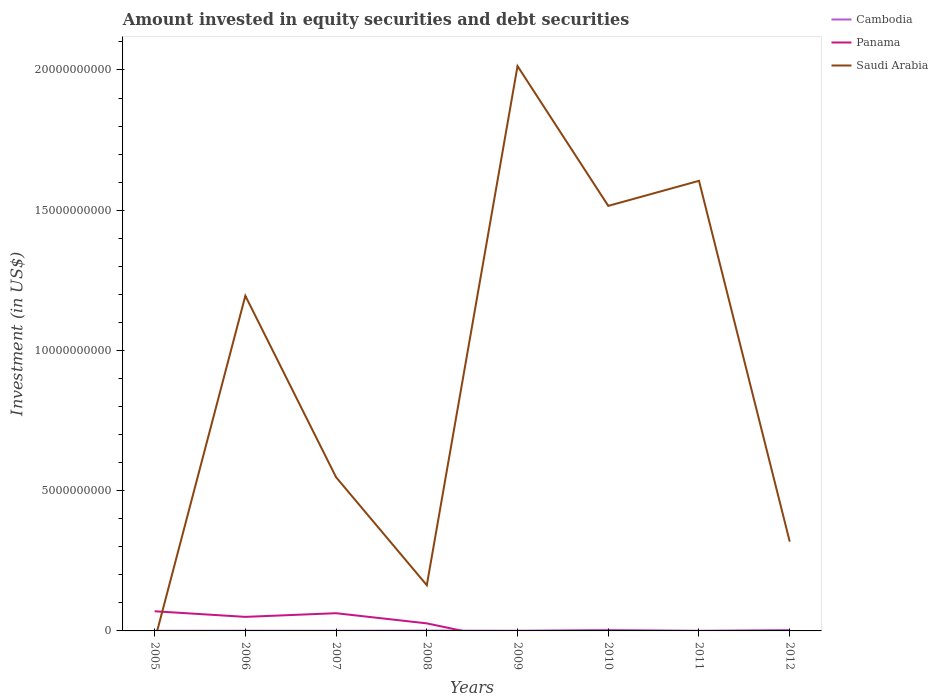What is the total amount invested in equity securities and debt securities in Saudi Arabia in the graph?
Your answer should be very brief. 4.98e+09. What is the difference between the highest and the second highest amount invested in equity securities and debt securities in Panama?
Your answer should be compact. 7.01e+08. What is the difference between the highest and the lowest amount invested in equity securities and debt securities in Saudi Arabia?
Your answer should be compact. 4. Is the amount invested in equity securities and debt securities in Panama strictly greater than the amount invested in equity securities and debt securities in Saudi Arabia over the years?
Offer a terse response. No. How many years are there in the graph?
Provide a succinct answer. 8. What is the difference between two consecutive major ticks on the Y-axis?
Ensure brevity in your answer.  5.00e+09. Are the values on the major ticks of Y-axis written in scientific E-notation?
Give a very brief answer. No. Does the graph contain grids?
Your response must be concise. No. Where does the legend appear in the graph?
Keep it short and to the point. Top right. How are the legend labels stacked?
Provide a short and direct response. Vertical. What is the title of the graph?
Provide a succinct answer. Amount invested in equity securities and debt securities. What is the label or title of the Y-axis?
Provide a short and direct response. Investment (in US$). What is the Investment (in US$) of Cambodia in 2005?
Offer a terse response. 4.87e+06. What is the Investment (in US$) of Panama in 2005?
Provide a short and direct response. 7.01e+08. What is the Investment (in US$) of Cambodia in 2006?
Give a very brief answer. 7.58e+06. What is the Investment (in US$) in Panama in 2006?
Give a very brief answer. 5.01e+08. What is the Investment (in US$) in Saudi Arabia in 2006?
Keep it short and to the point. 1.19e+1. What is the Investment (in US$) in Cambodia in 2007?
Provide a succinct answer. 6.33e+06. What is the Investment (in US$) in Panama in 2007?
Your answer should be very brief. 6.32e+08. What is the Investment (in US$) in Saudi Arabia in 2007?
Provide a succinct answer. 5.48e+09. What is the Investment (in US$) of Cambodia in 2008?
Make the answer very short. 1.16e+07. What is the Investment (in US$) in Panama in 2008?
Your answer should be compact. 2.70e+08. What is the Investment (in US$) of Saudi Arabia in 2008?
Provide a succinct answer. 1.63e+09. What is the Investment (in US$) in Cambodia in 2009?
Make the answer very short. 7.62e+06. What is the Investment (in US$) in Panama in 2009?
Your response must be concise. 0. What is the Investment (in US$) of Saudi Arabia in 2009?
Offer a terse response. 2.01e+1. What is the Investment (in US$) of Cambodia in 2010?
Offer a very short reply. 3.67e+07. What is the Investment (in US$) of Panama in 2010?
Provide a succinct answer. 0. What is the Investment (in US$) of Saudi Arabia in 2010?
Your response must be concise. 1.52e+1. What is the Investment (in US$) of Cambodia in 2011?
Your response must be concise. 6.14e+06. What is the Investment (in US$) in Panama in 2011?
Give a very brief answer. 0. What is the Investment (in US$) in Saudi Arabia in 2011?
Ensure brevity in your answer.  1.60e+1. What is the Investment (in US$) of Cambodia in 2012?
Your response must be concise. 3.42e+07. What is the Investment (in US$) of Panama in 2012?
Provide a short and direct response. 0. What is the Investment (in US$) in Saudi Arabia in 2012?
Offer a very short reply. 3.18e+09. Across all years, what is the maximum Investment (in US$) of Cambodia?
Your response must be concise. 3.67e+07. Across all years, what is the maximum Investment (in US$) of Panama?
Offer a terse response. 7.01e+08. Across all years, what is the maximum Investment (in US$) of Saudi Arabia?
Keep it short and to the point. 2.01e+1. Across all years, what is the minimum Investment (in US$) in Cambodia?
Provide a short and direct response. 4.87e+06. Across all years, what is the minimum Investment (in US$) in Saudi Arabia?
Your response must be concise. 0. What is the total Investment (in US$) in Cambodia in the graph?
Make the answer very short. 1.15e+08. What is the total Investment (in US$) in Panama in the graph?
Keep it short and to the point. 2.10e+09. What is the total Investment (in US$) of Saudi Arabia in the graph?
Make the answer very short. 7.36e+1. What is the difference between the Investment (in US$) in Cambodia in 2005 and that in 2006?
Make the answer very short. -2.72e+06. What is the difference between the Investment (in US$) in Panama in 2005 and that in 2006?
Provide a short and direct response. 2.00e+08. What is the difference between the Investment (in US$) of Cambodia in 2005 and that in 2007?
Your answer should be very brief. -1.47e+06. What is the difference between the Investment (in US$) of Panama in 2005 and that in 2007?
Offer a terse response. 6.92e+07. What is the difference between the Investment (in US$) of Cambodia in 2005 and that in 2008?
Your answer should be very brief. -6.72e+06. What is the difference between the Investment (in US$) of Panama in 2005 and that in 2008?
Give a very brief answer. 4.31e+08. What is the difference between the Investment (in US$) of Cambodia in 2005 and that in 2009?
Your response must be concise. -2.75e+06. What is the difference between the Investment (in US$) of Cambodia in 2005 and that in 2010?
Keep it short and to the point. -3.18e+07. What is the difference between the Investment (in US$) in Cambodia in 2005 and that in 2011?
Your answer should be very brief. -1.27e+06. What is the difference between the Investment (in US$) of Cambodia in 2005 and that in 2012?
Ensure brevity in your answer.  -2.93e+07. What is the difference between the Investment (in US$) of Cambodia in 2006 and that in 2007?
Provide a succinct answer. 1.25e+06. What is the difference between the Investment (in US$) of Panama in 2006 and that in 2007?
Your answer should be compact. -1.31e+08. What is the difference between the Investment (in US$) of Saudi Arabia in 2006 and that in 2007?
Your response must be concise. 6.47e+09. What is the difference between the Investment (in US$) of Cambodia in 2006 and that in 2008?
Your answer should be compact. -4.00e+06. What is the difference between the Investment (in US$) of Panama in 2006 and that in 2008?
Your response must be concise. 2.32e+08. What is the difference between the Investment (in US$) in Saudi Arabia in 2006 and that in 2008?
Keep it short and to the point. 1.03e+1. What is the difference between the Investment (in US$) of Cambodia in 2006 and that in 2009?
Your response must be concise. -3.82e+04. What is the difference between the Investment (in US$) of Saudi Arabia in 2006 and that in 2009?
Provide a short and direct response. -8.19e+09. What is the difference between the Investment (in US$) in Cambodia in 2006 and that in 2010?
Ensure brevity in your answer.  -2.91e+07. What is the difference between the Investment (in US$) of Saudi Arabia in 2006 and that in 2010?
Make the answer very short. -3.21e+09. What is the difference between the Investment (in US$) in Cambodia in 2006 and that in 2011?
Ensure brevity in your answer.  1.45e+06. What is the difference between the Investment (in US$) of Saudi Arabia in 2006 and that in 2011?
Your answer should be very brief. -4.10e+09. What is the difference between the Investment (in US$) of Cambodia in 2006 and that in 2012?
Offer a terse response. -2.66e+07. What is the difference between the Investment (in US$) in Saudi Arabia in 2006 and that in 2012?
Your response must be concise. 8.76e+09. What is the difference between the Investment (in US$) in Cambodia in 2007 and that in 2008?
Ensure brevity in your answer.  -5.25e+06. What is the difference between the Investment (in US$) of Panama in 2007 and that in 2008?
Provide a short and direct response. 3.62e+08. What is the difference between the Investment (in US$) of Saudi Arabia in 2007 and that in 2008?
Keep it short and to the point. 3.85e+09. What is the difference between the Investment (in US$) of Cambodia in 2007 and that in 2009?
Ensure brevity in your answer.  -1.29e+06. What is the difference between the Investment (in US$) of Saudi Arabia in 2007 and that in 2009?
Your response must be concise. -1.47e+1. What is the difference between the Investment (in US$) in Cambodia in 2007 and that in 2010?
Offer a very short reply. -3.03e+07. What is the difference between the Investment (in US$) of Saudi Arabia in 2007 and that in 2010?
Make the answer very short. -9.67e+09. What is the difference between the Investment (in US$) in Cambodia in 2007 and that in 2011?
Make the answer very short. 1.96e+05. What is the difference between the Investment (in US$) in Saudi Arabia in 2007 and that in 2011?
Make the answer very short. -1.06e+1. What is the difference between the Investment (in US$) of Cambodia in 2007 and that in 2012?
Provide a short and direct response. -2.78e+07. What is the difference between the Investment (in US$) of Saudi Arabia in 2007 and that in 2012?
Offer a very short reply. 2.30e+09. What is the difference between the Investment (in US$) in Cambodia in 2008 and that in 2009?
Keep it short and to the point. 3.97e+06. What is the difference between the Investment (in US$) of Saudi Arabia in 2008 and that in 2009?
Offer a very short reply. -1.85e+1. What is the difference between the Investment (in US$) of Cambodia in 2008 and that in 2010?
Offer a terse response. -2.51e+07. What is the difference between the Investment (in US$) in Saudi Arabia in 2008 and that in 2010?
Offer a very short reply. -1.35e+1. What is the difference between the Investment (in US$) of Cambodia in 2008 and that in 2011?
Your answer should be compact. 5.45e+06. What is the difference between the Investment (in US$) of Saudi Arabia in 2008 and that in 2011?
Your answer should be very brief. -1.44e+1. What is the difference between the Investment (in US$) in Cambodia in 2008 and that in 2012?
Offer a terse response. -2.26e+07. What is the difference between the Investment (in US$) of Saudi Arabia in 2008 and that in 2012?
Ensure brevity in your answer.  -1.55e+09. What is the difference between the Investment (in US$) of Cambodia in 2009 and that in 2010?
Your answer should be very brief. -2.90e+07. What is the difference between the Investment (in US$) in Saudi Arabia in 2009 and that in 2010?
Make the answer very short. 4.98e+09. What is the difference between the Investment (in US$) of Cambodia in 2009 and that in 2011?
Ensure brevity in your answer.  1.48e+06. What is the difference between the Investment (in US$) in Saudi Arabia in 2009 and that in 2011?
Make the answer very short. 4.09e+09. What is the difference between the Investment (in US$) of Cambodia in 2009 and that in 2012?
Ensure brevity in your answer.  -2.66e+07. What is the difference between the Investment (in US$) of Saudi Arabia in 2009 and that in 2012?
Ensure brevity in your answer.  1.70e+1. What is the difference between the Investment (in US$) of Cambodia in 2010 and that in 2011?
Your response must be concise. 3.05e+07. What is the difference between the Investment (in US$) of Saudi Arabia in 2010 and that in 2011?
Offer a very short reply. -8.93e+08. What is the difference between the Investment (in US$) in Cambodia in 2010 and that in 2012?
Keep it short and to the point. 2.49e+06. What is the difference between the Investment (in US$) in Saudi Arabia in 2010 and that in 2012?
Your answer should be compact. 1.20e+1. What is the difference between the Investment (in US$) of Cambodia in 2011 and that in 2012?
Your answer should be compact. -2.80e+07. What is the difference between the Investment (in US$) in Saudi Arabia in 2011 and that in 2012?
Your answer should be compact. 1.29e+1. What is the difference between the Investment (in US$) in Cambodia in 2005 and the Investment (in US$) in Panama in 2006?
Provide a short and direct response. -4.96e+08. What is the difference between the Investment (in US$) of Cambodia in 2005 and the Investment (in US$) of Saudi Arabia in 2006?
Ensure brevity in your answer.  -1.19e+1. What is the difference between the Investment (in US$) of Panama in 2005 and the Investment (in US$) of Saudi Arabia in 2006?
Give a very brief answer. -1.12e+1. What is the difference between the Investment (in US$) in Cambodia in 2005 and the Investment (in US$) in Panama in 2007?
Your answer should be compact. -6.27e+08. What is the difference between the Investment (in US$) of Cambodia in 2005 and the Investment (in US$) of Saudi Arabia in 2007?
Provide a short and direct response. -5.47e+09. What is the difference between the Investment (in US$) of Panama in 2005 and the Investment (in US$) of Saudi Arabia in 2007?
Provide a short and direct response. -4.78e+09. What is the difference between the Investment (in US$) of Cambodia in 2005 and the Investment (in US$) of Panama in 2008?
Your answer should be very brief. -2.65e+08. What is the difference between the Investment (in US$) in Cambodia in 2005 and the Investment (in US$) in Saudi Arabia in 2008?
Your answer should be very brief. -1.63e+09. What is the difference between the Investment (in US$) of Panama in 2005 and the Investment (in US$) of Saudi Arabia in 2008?
Your answer should be very brief. -9.30e+08. What is the difference between the Investment (in US$) of Cambodia in 2005 and the Investment (in US$) of Saudi Arabia in 2009?
Your response must be concise. -2.01e+1. What is the difference between the Investment (in US$) in Panama in 2005 and the Investment (in US$) in Saudi Arabia in 2009?
Your answer should be compact. -1.94e+1. What is the difference between the Investment (in US$) in Cambodia in 2005 and the Investment (in US$) in Saudi Arabia in 2010?
Your response must be concise. -1.51e+1. What is the difference between the Investment (in US$) of Panama in 2005 and the Investment (in US$) of Saudi Arabia in 2010?
Keep it short and to the point. -1.45e+1. What is the difference between the Investment (in US$) in Cambodia in 2005 and the Investment (in US$) in Saudi Arabia in 2011?
Your answer should be very brief. -1.60e+1. What is the difference between the Investment (in US$) of Panama in 2005 and the Investment (in US$) of Saudi Arabia in 2011?
Keep it short and to the point. -1.53e+1. What is the difference between the Investment (in US$) of Cambodia in 2005 and the Investment (in US$) of Saudi Arabia in 2012?
Make the answer very short. -3.18e+09. What is the difference between the Investment (in US$) in Panama in 2005 and the Investment (in US$) in Saudi Arabia in 2012?
Keep it short and to the point. -2.48e+09. What is the difference between the Investment (in US$) in Cambodia in 2006 and the Investment (in US$) in Panama in 2007?
Provide a short and direct response. -6.24e+08. What is the difference between the Investment (in US$) in Cambodia in 2006 and the Investment (in US$) in Saudi Arabia in 2007?
Provide a short and direct response. -5.47e+09. What is the difference between the Investment (in US$) of Panama in 2006 and the Investment (in US$) of Saudi Arabia in 2007?
Your response must be concise. -4.98e+09. What is the difference between the Investment (in US$) of Cambodia in 2006 and the Investment (in US$) of Panama in 2008?
Give a very brief answer. -2.62e+08. What is the difference between the Investment (in US$) of Cambodia in 2006 and the Investment (in US$) of Saudi Arabia in 2008?
Offer a very short reply. -1.62e+09. What is the difference between the Investment (in US$) in Panama in 2006 and the Investment (in US$) in Saudi Arabia in 2008?
Offer a very short reply. -1.13e+09. What is the difference between the Investment (in US$) of Cambodia in 2006 and the Investment (in US$) of Saudi Arabia in 2009?
Provide a short and direct response. -2.01e+1. What is the difference between the Investment (in US$) of Panama in 2006 and the Investment (in US$) of Saudi Arabia in 2009?
Offer a terse response. -1.96e+1. What is the difference between the Investment (in US$) in Cambodia in 2006 and the Investment (in US$) in Saudi Arabia in 2010?
Provide a short and direct response. -1.51e+1. What is the difference between the Investment (in US$) of Panama in 2006 and the Investment (in US$) of Saudi Arabia in 2010?
Your answer should be very brief. -1.47e+1. What is the difference between the Investment (in US$) in Cambodia in 2006 and the Investment (in US$) in Saudi Arabia in 2011?
Your response must be concise. -1.60e+1. What is the difference between the Investment (in US$) of Panama in 2006 and the Investment (in US$) of Saudi Arabia in 2011?
Offer a terse response. -1.55e+1. What is the difference between the Investment (in US$) of Cambodia in 2006 and the Investment (in US$) of Saudi Arabia in 2012?
Your response must be concise. -3.18e+09. What is the difference between the Investment (in US$) of Panama in 2006 and the Investment (in US$) of Saudi Arabia in 2012?
Ensure brevity in your answer.  -2.68e+09. What is the difference between the Investment (in US$) of Cambodia in 2007 and the Investment (in US$) of Panama in 2008?
Provide a short and direct response. -2.63e+08. What is the difference between the Investment (in US$) in Cambodia in 2007 and the Investment (in US$) in Saudi Arabia in 2008?
Offer a terse response. -1.62e+09. What is the difference between the Investment (in US$) in Panama in 2007 and the Investment (in US$) in Saudi Arabia in 2008?
Your answer should be very brief. -9.99e+08. What is the difference between the Investment (in US$) in Cambodia in 2007 and the Investment (in US$) in Saudi Arabia in 2009?
Your response must be concise. -2.01e+1. What is the difference between the Investment (in US$) of Panama in 2007 and the Investment (in US$) of Saudi Arabia in 2009?
Provide a short and direct response. -1.95e+1. What is the difference between the Investment (in US$) of Cambodia in 2007 and the Investment (in US$) of Saudi Arabia in 2010?
Provide a succinct answer. -1.51e+1. What is the difference between the Investment (in US$) of Panama in 2007 and the Investment (in US$) of Saudi Arabia in 2010?
Offer a terse response. -1.45e+1. What is the difference between the Investment (in US$) in Cambodia in 2007 and the Investment (in US$) in Saudi Arabia in 2011?
Provide a succinct answer. -1.60e+1. What is the difference between the Investment (in US$) of Panama in 2007 and the Investment (in US$) of Saudi Arabia in 2011?
Give a very brief answer. -1.54e+1. What is the difference between the Investment (in US$) in Cambodia in 2007 and the Investment (in US$) in Saudi Arabia in 2012?
Your response must be concise. -3.18e+09. What is the difference between the Investment (in US$) of Panama in 2007 and the Investment (in US$) of Saudi Arabia in 2012?
Give a very brief answer. -2.55e+09. What is the difference between the Investment (in US$) of Cambodia in 2008 and the Investment (in US$) of Saudi Arabia in 2009?
Your answer should be compact. -2.01e+1. What is the difference between the Investment (in US$) in Panama in 2008 and the Investment (in US$) in Saudi Arabia in 2009?
Your answer should be very brief. -1.99e+1. What is the difference between the Investment (in US$) in Cambodia in 2008 and the Investment (in US$) in Saudi Arabia in 2010?
Give a very brief answer. -1.51e+1. What is the difference between the Investment (in US$) in Panama in 2008 and the Investment (in US$) in Saudi Arabia in 2010?
Provide a short and direct response. -1.49e+1. What is the difference between the Investment (in US$) of Cambodia in 2008 and the Investment (in US$) of Saudi Arabia in 2011?
Your answer should be very brief. -1.60e+1. What is the difference between the Investment (in US$) of Panama in 2008 and the Investment (in US$) of Saudi Arabia in 2011?
Give a very brief answer. -1.58e+1. What is the difference between the Investment (in US$) in Cambodia in 2008 and the Investment (in US$) in Saudi Arabia in 2012?
Your answer should be compact. -3.17e+09. What is the difference between the Investment (in US$) in Panama in 2008 and the Investment (in US$) in Saudi Arabia in 2012?
Keep it short and to the point. -2.91e+09. What is the difference between the Investment (in US$) of Cambodia in 2009 and the Investment (in US$) of Saudi Arabia in 2010?
Provide a succinct answer. -1.51e+1. What is the difference between the Investment (in US$) of Cambodia in 2009 and the Investment (in US$) of Saudi Arabia in 2011?
Provide a short and direct response. -1.60e+1. What is the difference between the Investment (in US$) in Cambodia in 2009 and the Investment (in US$) in Saudi Arabia in 2012?
Provide a succinct answer. -3.18e+09. What is the difference between the Investment (in US$) of Cambodia in 2010 and the Investment (in US$) of Saudi Arabia in 2011?
Make the answer very short. -1.60e+1. What is the difference between the Investment (in US$) in Cambodia in 2010 and the Investment (in US$) in Saudi Arabia in 2012?
Your response must be concise. -3.15e+09. What is the difference between the Investment (in US$) in Cambodia in 2011 and the Investment (in US$) in Saudi Arabia in 2012?
Make the answer very short. -3.18e+09. What is the average Investment (in US$) in Cambodia per year?
Give a very brief answer. 1.44e+07. What is the average Investment (in US$) of Panama per year?
Offer a very short reply. 2.63e+08. What is the average Investment (in US$) of Saudi Arabia per year?
Ensure brevity in your answer.  9.20e+09. In the year 2005, what is the difference between the Investment (in US$) in Cambodia and Investment (in US$) in Panama?
Offer a very short reply. -6.96e+08. In the year 2006, what is the difference between the Investment (in US$) of Cambodia and Investment (in US$) of Panama?
Offer a terse response. -4.93e+08. In the year 2006, what is the difference between the Investment (in US$) in Cambodia and Investment (in US$) in Saudi Arabia?
Your answer should be compact. -1.19e+1. In the year 2006, what is the difference between the Investment (in US$) in Panama and Investment (in US$) in Saudi Arabia?
Your answer should be compact. -1.14e+1. In the year 2007, what is the difference between the Investment (in US$) in Cambodia and Investment (in US$) in Panama?
Provide a succinct answer. -6.25e+08. In the year 2007, what is the difference between the Investment (in US$) in Cambodia and Investment (in US$) in Saudi Arabia?
Your answer should be very brief. -5.47e+09. In the year 2007, what is the difference between the Investment (in US$) of Panama and Investment (in US$) of Saudi Arabia?
Offer a terse response. -4.85e+09. In the year 2008, what is the difference between the Investment (in US$) in Cambodia and Investment (in US$) in Panama?
Provide a short and direct response. -2.58e+08. In the year 2008, what is the difference between the Investment (in US$) of Cambodia and Investment (in US$) of Saudi Arabia?
Keep it short and to the point. -1.62e+09. In the year 2008, what is the difference between the Investment (in US$) of Panama and Investment (in US$) of Saudi Arabia?
Make the answer very short. -1.36e+09. In the year 2009, what is the difference between the Investment (in US$) in Cambodia and Investment (in US$) in Saudi Arabia?
Give a very brief answer. -2.01e+1. In the year 2010, what is the difference between the Investment (in US$) of Cambodia and Investment (in US$) of Saudi Arabia?
Offer a terse response. -1.51e+1. In the year 2011, what is the difference between the Investment (in US$) in Cambodia and Investment (in US$) in Saudi Arabia?
Your answer should be compact. -1.60e+1. In the year 2012, what is the difference between the Investment (in US$) in Cambodia and Investment (in US$) in Saudi Arabia?
Offer a very short reply. -3.15e+09. What is the ratio of the Investment (in US$) in Cambodia in 2005 to that in 2006?
Your answer should be very brief. 0.64. What is the ratio of the Investment (in US$) in Panama in 2005 to that in 2006?
Ensure brevity in your answer.  1.4. What is the ratio of the Investment (in US$) in Cambodia in 2005 to that in 2007?
Your answer should be very brief. 0.77. What is the ratio of the Investment (in US$) of Panama in 2005 to that in 2007?
Provide a succinct answer. 1.11. What is the ratio of the Investment (in US$) in Cambodia in 2005 to that in 2008?
Ensure brevity in your answer.  0.42. What is the ratio of the Investment (in US$) of Panama in 2005 to that in 2008?
Keep it short and to the point. 2.6. What is the ratio of the Investment (in US$) in Cambodia in 2005 to that in 2009?
Offer a terse response. 0.64. What is the ratio of the Investment (in US$) in Cambodia in 2005 to that in 2010?
Provide a succinct answer. 0.13. What is the ratio of the Investment (in US$) of Cambodia in 2005 to that in 2011?
Keep it short and to the point. 0.79. What is the ratio of the Investment (in US$) of Cambodia in 2005 to that in 2012?
Your answer should be compact. 0.14. What is the ratio of the Investment (in US$) in Cambodia in 2006 to that in 2007?
Offer a very short reply. 1.2. What is the ratio of the Investment (in US$) in Panama in 2006 to that in 2007?
Keep it short and to the point. 0.79. What is the ratio of the Investment (in US$) of Saudi Arabia in 2006 to that in 2007?
Provide a short and direct response. 2.18. What is the ratio of the Investment (in US$) of Cambodia in 2006 to that in 2008?
Your response must be concise. 0.65. What is the ratio of the Investment (in US$) of Panama in 2006 to that in 2008?
Provide a short and direct response. 1.86. What is the ratio of the Investment (in US$) of Saudi Arabia in 2006 to that in 2008?
Give a very brief answer. 7.33. What is the ratio of the Investment (in US$) of Cambodia in 2006 to that in 2009?
Offer a very short reply. 0.99. What is the ratio of the Investment (in US$) in Saudi Arabia in 2006 to that in 2009?
Your answer should be compact. 0.59. What is the ratio of the Investment (in US$) of Cambodia in 2006 to that in 2010?
Keep it short and to the point. 0.21. What is the ratio of the Investment (in US$) of Saudi Arabia in 2006 to that in 2010?
Your answer should be compact. 0.79. What is the ratio of the Investment (in US$) in Cambodia in 2006 to that in 2011?
Offer a terse response. 1.24. What is the ratio of the Investment (in US$) in Saudi Arabia in 2006 to that in 2011?
Your answer should be compact. 0.74. What is the ratio of the Investment (in US$) of Cambodia in 2006 to that in 2012?
Your answer should be compact. 0.22. What is the ratio of the Investment (in US$) in Saudi Arabia in 2006 to that in 2012?
Make the answer very short. 3.75. What is the ratio of the Investment (in US$) of Cambodia in 2007 to that in 2008?
Ensure brevity in your answer.  0.55. What is the ratio of the Investment (in US$) of Panama in 2007 to that in 2008?
Provide a short and direct response. 2.34. What is the ratio of the Investment (in US$) of Saudi Arabia in 2007 to that in 2008?
Provide a short and direct response. 3.36. What is the ratio of the Investment (in US$) of Cambodia in 2007 to that in 2009?
Offer a very short reply. 0.83. What is the ratio of the Investment (in US$) in Saudi Arabia in 2007 to that in 2009?
Your answer should be compact. 0.27. What is the ratio of the Investment (in US$) of Cambodia in 2007 to that in 2010?
Provide a short and direct response. 0.17. What is the ratio of the Investment (in US$) in Saudi Arabia in 2007 to that in 2010?
Your answer should be compact. 0.36. What is the ratio of the Investment (in US$) of Cambodia in 2007 to that in 2011?
Give a very brief answer. 1.03. What is the ratio of the Investment (in US$) of Saudi Arabia in 2007 to that in 2011?
Make the answer very short. 0.34. What is the ratio of the Investment (in US$) of Cambodia in 2007 to that in 2012?
Offer a terse response. 0.19. What is the ratio of the Investment (in US$) of Saudi Arabia in 2007 to that in 2012?
Make the answer very short. 1.72. What is the ratio of the Investment (in US$) in Cambodia in 2008 to that in 2009?
Keep it short and to the point. 1.52. What is the ratio of the Investment (in US$) of Saudi Arabia in 2008 to that in 2009?
Your answer should be very brief. 0.08. What is the ratio of the Investment (in US$) in Cambodia in 2008 to that in 2010?
Your answer should be compact. 0.32. What is the ratio of the Investment (in US$) of Saudi Arabia in 2008 to that in 2010?
Keep it short and to the point. 0.11. What is the ratio of the Investment (in US$) in Cambodia in 2008 to that in 2011?
Offer a terse response. 1.89. What is the ratio of the Investment (in US$) in Saudi Arabia in 2008 to that in 2011?
Provide a short and direct response. 0.1. What is the ratio of the Investment (in US$) of Cambodia in 2008 to that in 2012?
Provide a short and direct response. 0.34. What is the ratio of the Investment (in US$) in Saudi Arabia in 2008 to that in 2012?
Your answer should be very brief. 0.51. What is the ratio of the Investment (in US$) in Cambodia in 2009 to that in 2010?
Provide a succinct answer. 0.21. What is the ratio of the Investment (in US$) of Saudi Arabia in 2009 to that in 2010?
Offer a very short reply. 1.33. What is the ratio of the Investment (in US$) in Cambodia in 2009 to that in 2011?
Provide a succinct answer. 1.24. What is the ratio of the Investment (in US$) of Saudi Arabia in 2009 to that in 2011?
Keep it short and to the point. 1.25. What is the ratio of the Investment (in US$) of Cambodia in 2009 to that in 2012?
Give a very brief answer. 0.22. What is the ratio of the Investment (in US$) in Saudi Arabia in 2009 to that in 2012?
Keep it short and to the point. 6.32. What is the ratio of the Investment (in US$) in Cambodia in 2010 to that in 2011?
Ensure brevity in your answer.  5.97. What is the ratio of the Investment (in US$) in Saudi Arabia in 2010 to that in 2011?
Give a very brief answer. 0.94. What is the ratio of the Investment (in US$) of Cambodia in 2010 to that in 2012?
Provide a succinct answer. 1.07. What is the ratio of the Investment (in US$) of Saudi Arabia in 2010 to that in 2012?
Ensure brevity in your answer.  4.76. What is the ratio of the Investment (in US$) in Cambodia in 2011 to that in 2012?
Provide a short and direct response. 0.18. What is the ratio of the Investment (in US$) in Saudi Arabia in 2011 to that in 2012?
Make the answer very short. 5.04. What is the difference between the highest and the second highest Investment (in US$) in Cambodia?
Your answer should be compact. 2.49e+06. What is the difference between the highest and the second highest Investment (in US$) in Panama?
Your answer should be very brief. 6.92e+07. What is the difference between the highest and the second highest Investment (in US$) in Saudi Arabia?
Make the answer very short. 4.09e+09. What is the difference between the highest and the lowest Investment (in US$) of Cambodia?
Make the answer very short. 3.18e+07. What is the difference between the highest and the lowest Investment (in US$) in Panama?
Offer a terse response. 7.01e+08. What is the difference between the highest and the lowest Investment (in US$) of Saudi Arabia?
Offer a very short reply. 2.01e+1. 